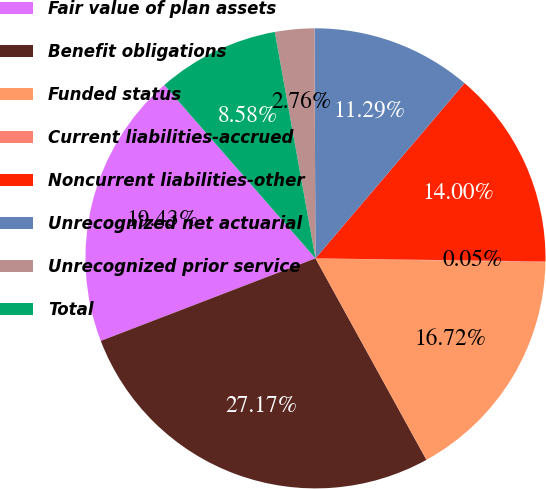Convert chart. <chart><loc_0><loc_0><loc_500><loc_500><pie_chart><fcel>Fair value of plan assets<fcel>Benefit obligations<fcel>Funded status<fcel>Current liabilities-accrued<fcel>Noncurrent liabilities-other<fcel>Unrecognized net actuarial<fcel>Unrecognized prior service<fcel>Total<nl><fcel>19.43%<fcel>27.17%<fcel>16.72%<fcel>0.05%<fcel>14.0%<fcel>11.29%<fcel>2.76%<fcel>8.58%<nl></chart> 